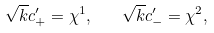Convert formula to latex. <formula><loc_0><loc_0><loc_500><loc_500>\sqrt { k } c ^ { \prime } _ { + } = \chi ^ { 1 } , \quad \sqrt { k } c ^ { \prime } _ { - } = \chi ^ { 2 } ,</formula> 